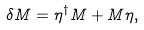<formula> <loc_0><loc_0><loc_500><loc_500>\delta M = \eta ^ { \dagger } M + M \eta ,</formula> 